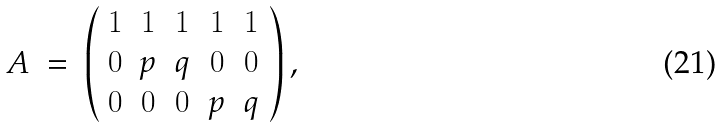<formula> <loc_0><loc_0><loc_500><loc_500>A \ = \ \left ( \begin{array} { c c c c c c } 1 & 1 & 1 & 1 & 1 \\ 0 & p & q & 0 & 0 \\ 0 & 0 & 0 & p & q \end{array} \right ) ,</formula> 